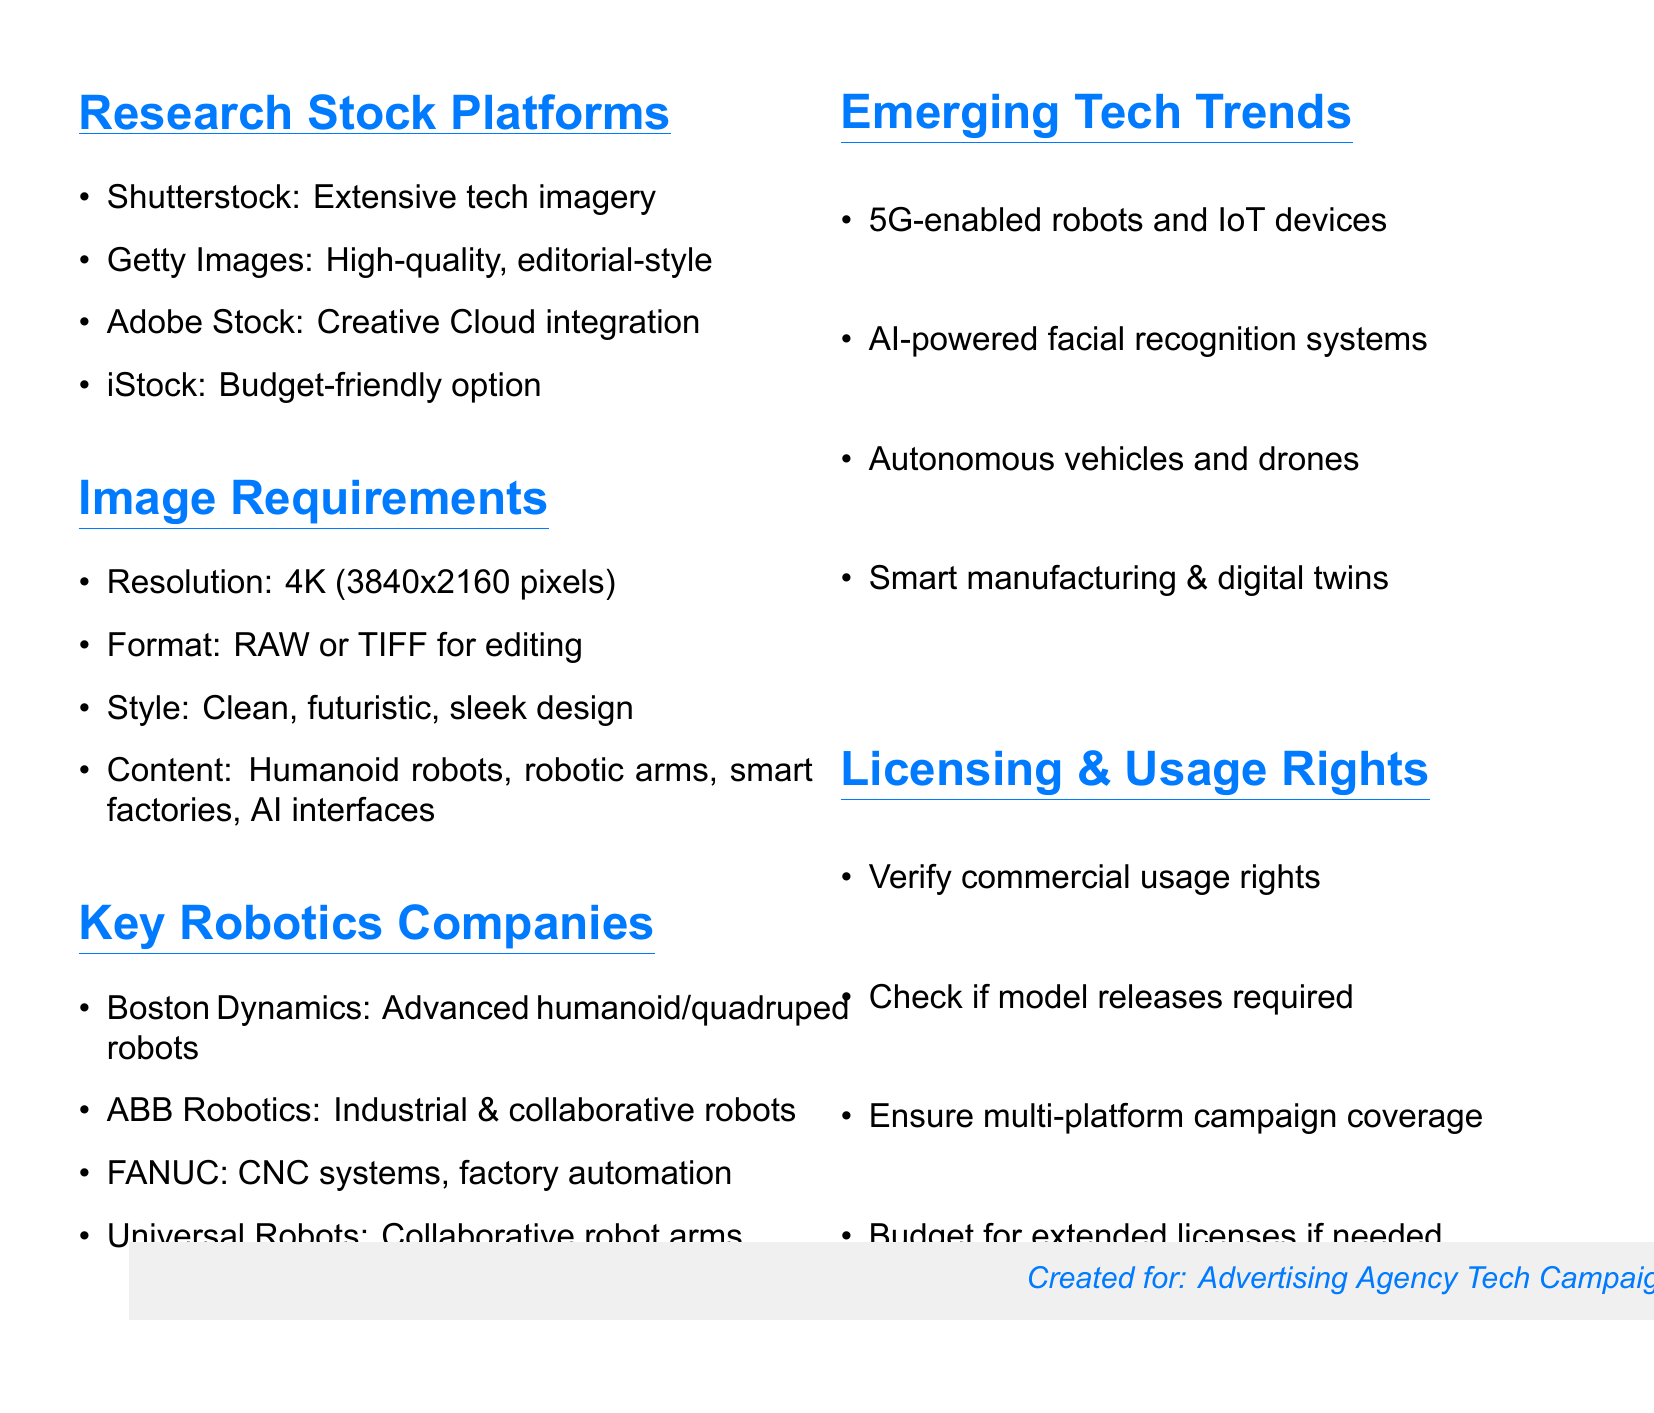What is the minimum resolution required for images? The document specifies a minimum resolution of 4K, which is defined as 3840x2160 pixels.
Answer: 4K (3840x2160 pixels) Which stock platform is known for extensive tech imagery? The document lists Shutterstock as known for its extensive tech imagery.
Answer: Shutterstock What type of robots does Boston Dynamics specialize in? According to the document, Boston Dynamics focuses on advanced humanoid and quadruped robots.
Answer: Humanoid and quadruped robots What emerging tech trend involves connected devices? The document mentions 5G-enabled robots and IoT devices as an emerging tech trend.
Answer: 5G-enabled robots and IoT devices What should be checked regarding licensing rights? The document indicates commercial usage rights should be verified.
Answer: Commercial usage rights What file formats are recommended for images? The document recommends RAW or TIFF file formats for maximum editing flexibility.
Answer: RAW or TIFF How many popular stock image platforms are listed? The document lists four popular stock image platforms.
Answer: Four What is the budget-friendly option mentioned in the stock platforms section? The document identifies iStock as the budget-friendly option with a good selection.
Answer: iStock What type of images should have a clean and futuristic style? The document states that the style requirement is for robotics and automation technology images.
Answer: Robotics and automation technology images 